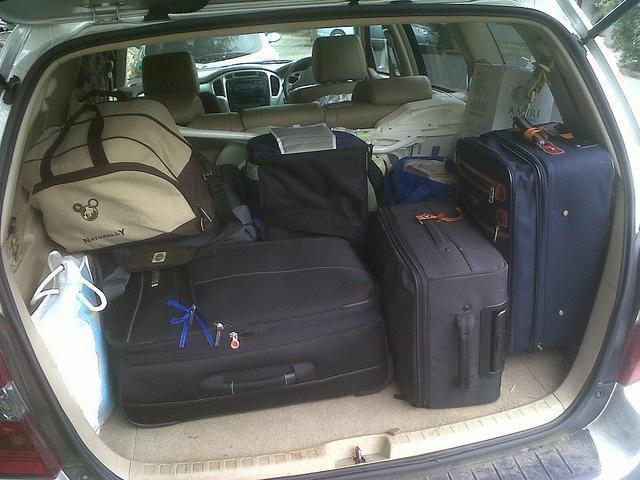How many suitcases are there?
Give a very brief answer. 3. How many backpacks are there?
Give a very brief answer. 2. 